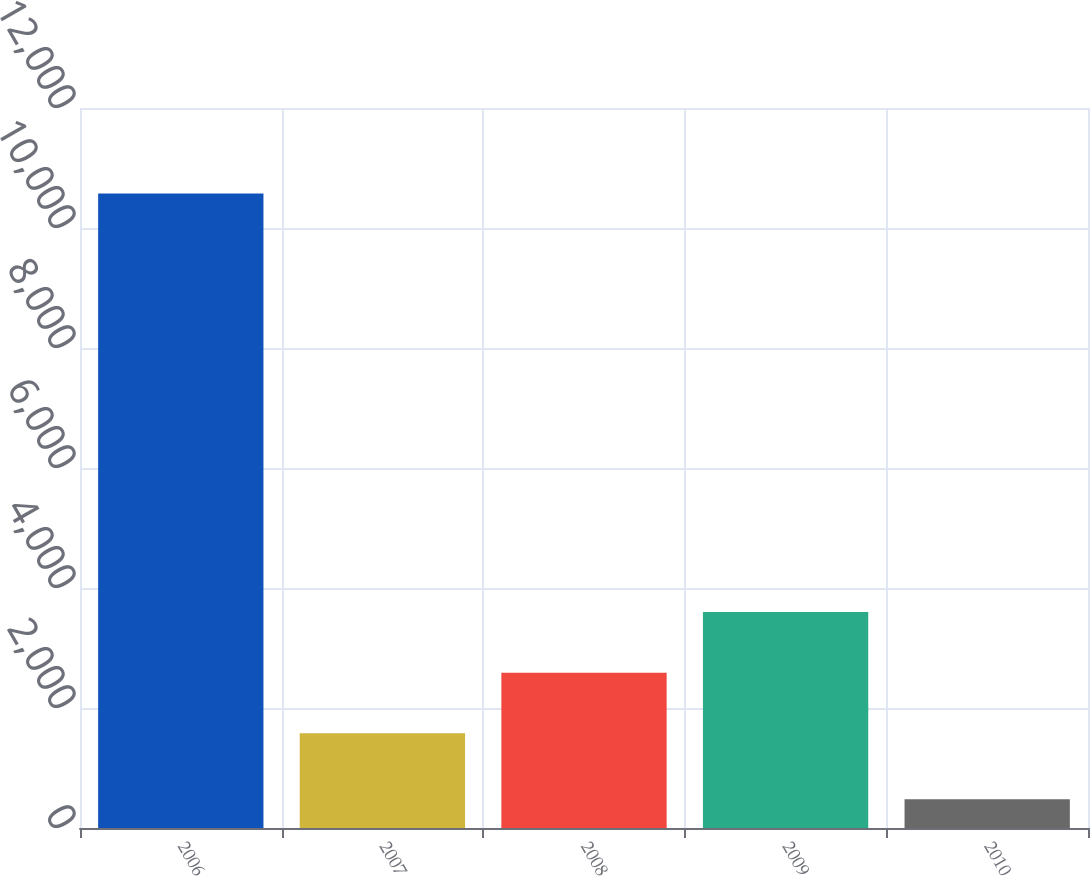Convert chart. <chart><loc_0><loc_0><loc_500><loc_500><bar_chart><fcel>2006<fcel>2007<fcel>2008<fcel>2009<fcel>2010<nl><fcel>10573<fcel>1580<fcel>2589.3<fcel>3598.6<fcel>480<nl></chart> 